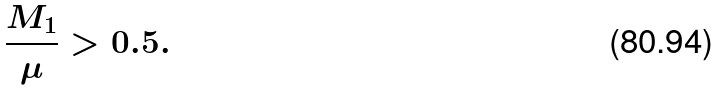<formula> <loc_0><loc_0><loc_500><loc_500>\frac { M _ { 1 } } { \mu } > 0 . 5 .</formula> 